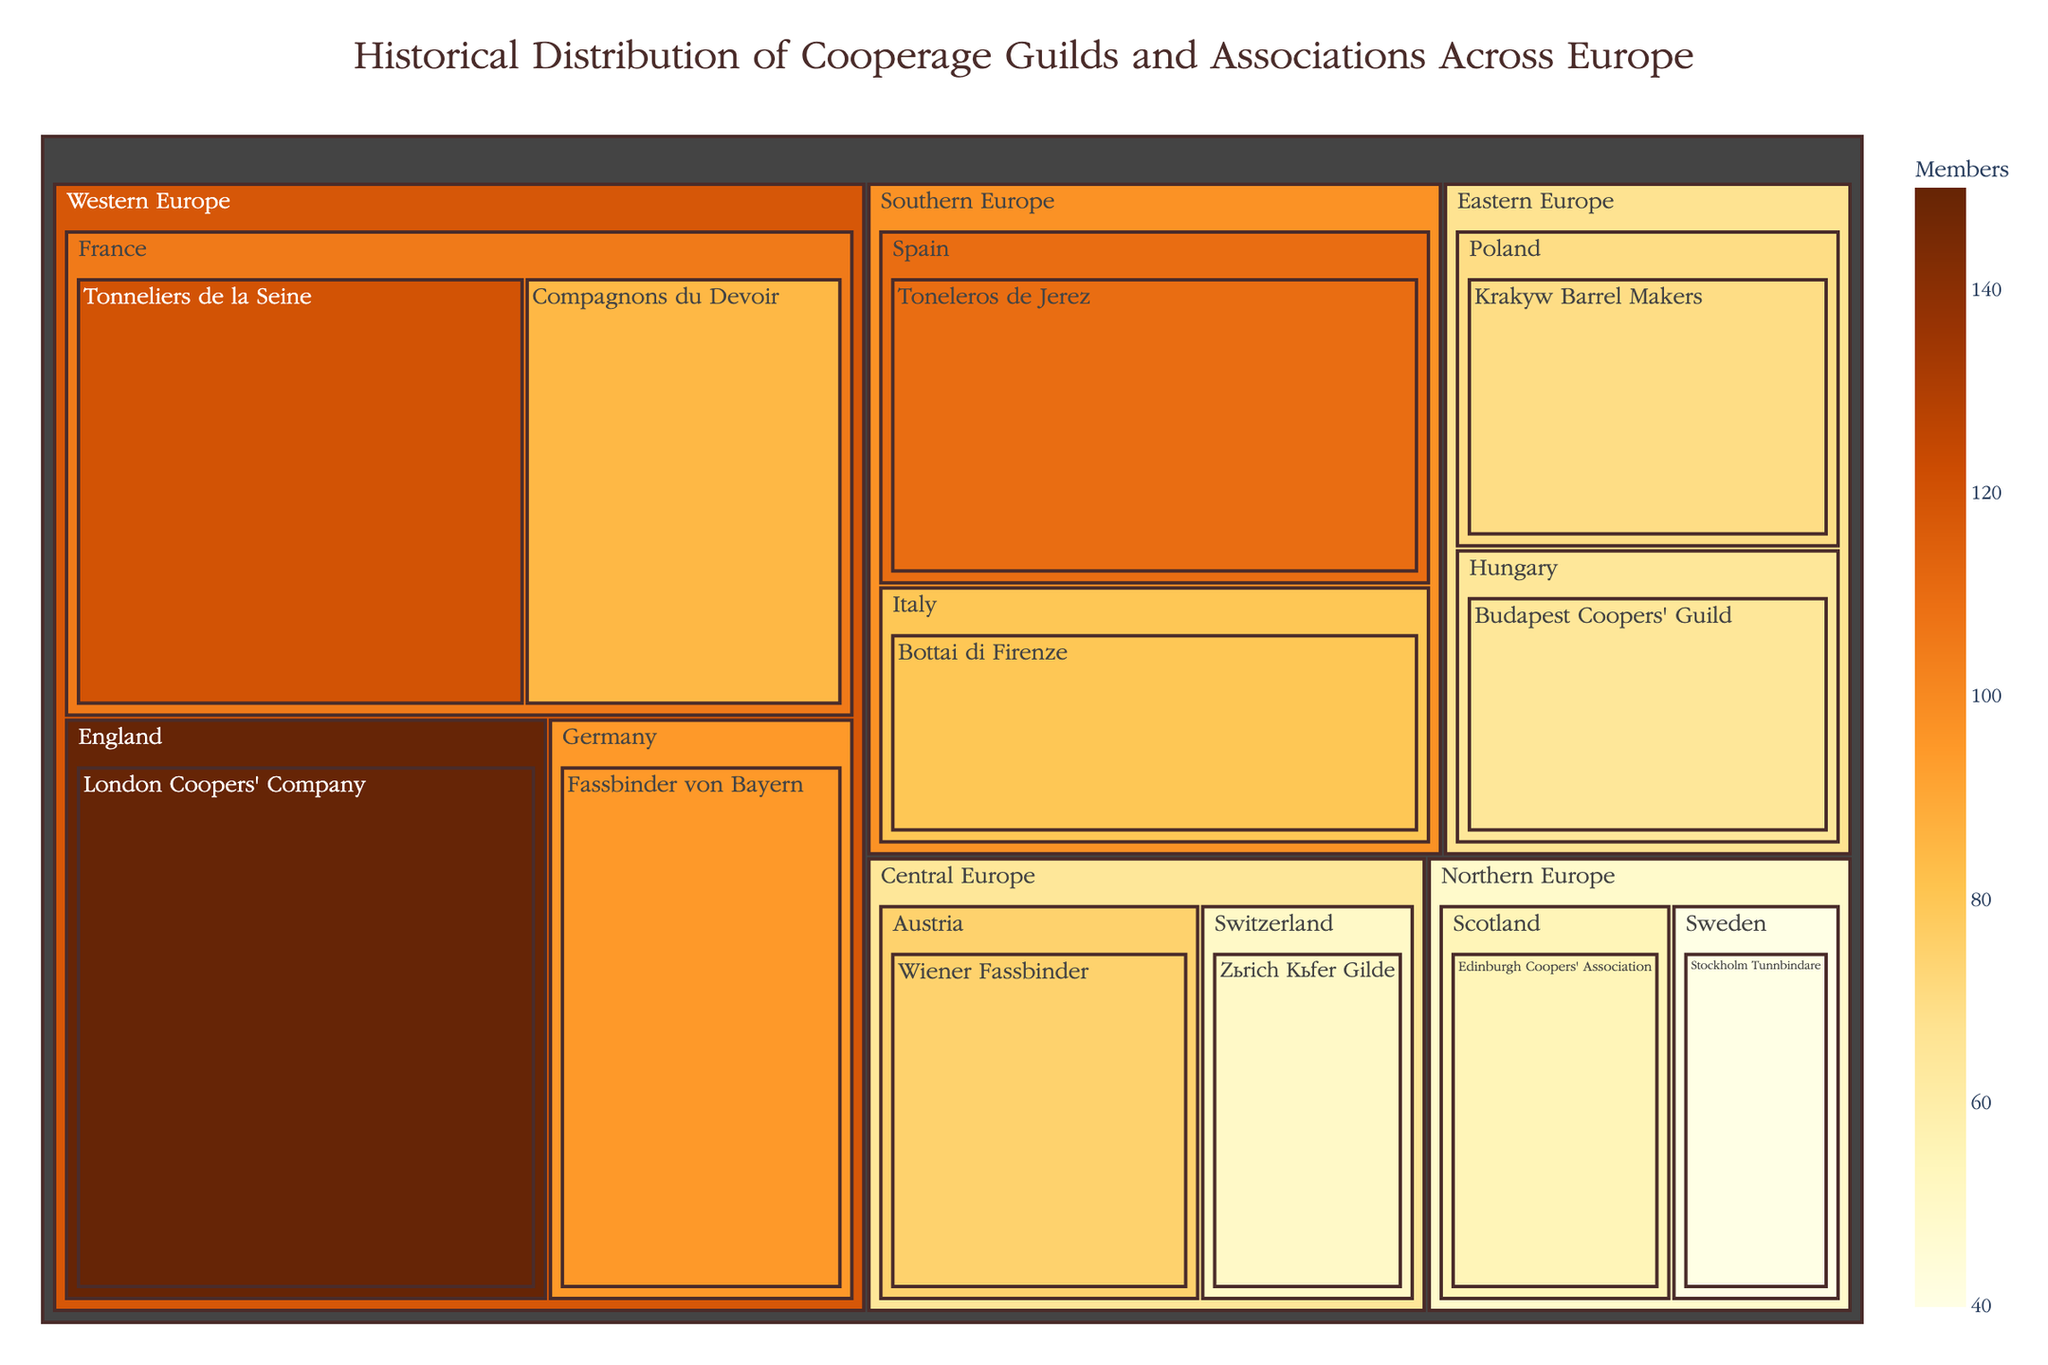What is the title of the treemap? The title is displayed at the top of the figure in a prominent font and color. It states the main topic of the visual.
Answer: Historical Distribution of Cooperage Guilds and Associations Across Europe Which country has the guild with the highest number of members? To find this, look for the country block with the largest individual guild block inside it. The largest block represents the London Coopers' Company in England.
Answer: England How many total members are there in Western Europe? Sum the number of members in all guilds listed under Western Europe: 120 (Tonneliers de la Seine) + 85 (Compagnons du Devoir) + 95 (Fassbinder von Bayern) + 150 (London Coopers' Company) = 450
Answer: 450 Which region has the smallest guild in terms of membership, and what is the guild? Identify the smallest individual block across the entire treemap, which is the Stockholm Tunnbindare in Sweden under Northern Europe.
Answer: Northern Europe, Stockholm Tunnbindare Compare the membership of the Kraków Barrel Makers and the Budapest Coopers' Guild. Which has more members and by how much? Look at the respective blocks for each guild. The Kraków Barrel Makers has 70 members, and the Budapest Coopers' Guild has 65. 70 - 65 = 5.
Answer: Kraków Barrel Makers by 5 members How many guilds are there in Central Europe, and what are their names? Count the number of country blocks under Central Europe and list their names. Central Europe includes Austria (Wiener Fassbinder) and Switzerland (Zürich Küfer Gilde).
Answer: Two, Wiener Fassbinder and Zürich Küfer Gilde Which region has the highest aggregate number of members, and what is this number? Sum the individual members for each region and compare: Western Europe has 450, Eastern Europe has 135, Southern Europe has 190, Northern Europe has 95, Central Europe has 125. Western Europe has the highest with 450 members.
Answer: Western Europe, 450 members What is the average number of members per guild in Southern Europe? First sum the number of members in Southern Europe's guilds (80 in Bottai di Firenze + 110 in Toneleros de Jerez = 190), then divide by the number of guilds (2). 190/2 = 95.
Answer: 95 Which guild has almost twice the number of members as the Stockholm Tunnbindare? The Stockholm Tunnbindare has 40 members. Look for a guild with approximately double members: 80, which is Bottai di Firenze in Italy.
Answer: Bottai di Firenze Compare the sizes of the Tonneliers de la Seine in France and the Toneleros de Jerez in Spain. Which one is larger and by how much? Tonneliers de la Seine has 120 members, and Toneleros de Jerez has 110 members. 120 - 110 = 10, so Tonneliers de la Seine is larger by 10 members.
Answer: Tonneliers de la Seine by 10 members 